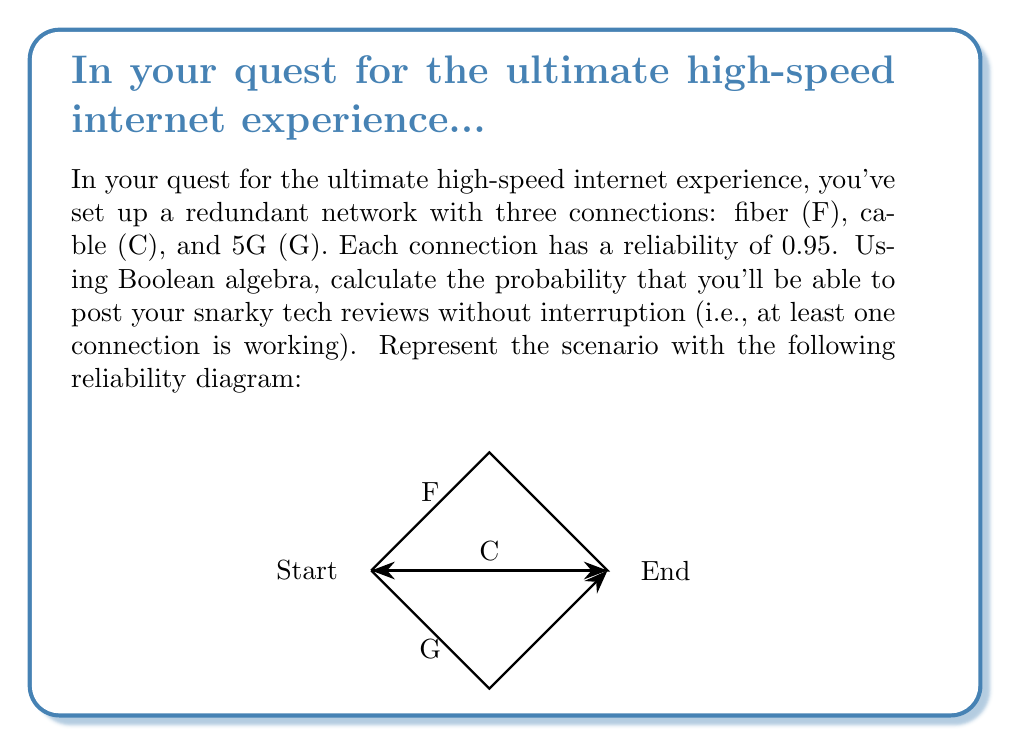Provide a solution to this math problem. Let's approach this step-by-step:

1) First, we need to understand what the question is asking. We want the probability that at least one connection is working, which is the opposite of all connections failing.

2) Let's define our events:
   $F$ = Fiber working
   $C$ = Cable working
   $G$ = 5G working

3) The probability of each connection working is 0.95, so the probability of each failing is 1 - 0.95 = 0.05.

4) Using Boolean algebra, we can express the probability of all connections failing as:
   $P(\text{all fail}) = P(\overline{F} \wedge \overline{C} \wedge \overline{G})$

5) Since the events are independent, we can multiply their probabilities:
   $P(\text{all fail}) = P(\overline{F}) \cdot P(\overline{C}) \cdot P(\overline{G}) = 0.05 \cdot 0.05 \cdot 0.05 = 0.000125$

6) Now, the probability of at least one connection working is the opposite of all failing:
   $P(\text{at least one working}) = 1 - P(\text{all fail}) = 1 - 0.000125 = 0.999875$

7) We can also express this using Boolean algebra:
   $P(F \vee C \vee G) = 1 - P(\overline{F} \wedge \overline{C} \wedge \overline{G})$

8) This result means there's a 99.9875% chance that at least one connection will be working.
Answer: 0.999875 